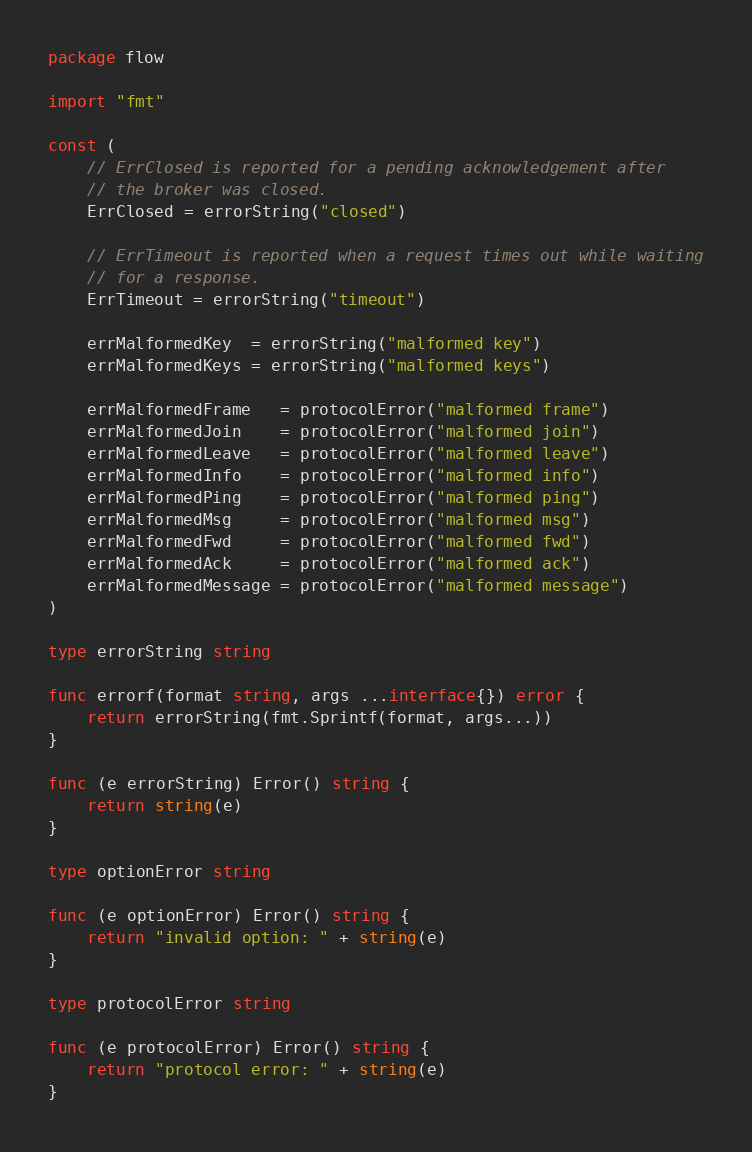<code> <loc_0><loc_0><loc_500><loc_500><_Go_>package flow

import "fmt"

const (
	// ErrClosed is reported for a pending acknowledgement after
	// the broker was closed.
	ErrClosed = errorString("closed")

	// ErrTimeout is reported when a request times out while waiting
	// for a response.
	ErrTimeout = errorString("timeout")

	errMalformedKey  = errorString("malformed key")
	errMalformedKeys = errorString("malformed keys")

	errMalformedFrame   = protocolError("malformed frame")
	errMalformedJoin    = protocolError("malformed join")
	errMalformedLeave   = protocolError("malformed leave")
	errMalformedInfo    = protocolError("malformed info")
	errMalformedPing    = protocolError("malformed ping")
	errMalformedMsg     = protocolError("malformed msg")
	errMalformedFwd     = protocolError("malformed fwd")
	errMalformedAck     = protocolError("malformed ack")
	errMalformedMessage = protocolError("malformed message")
)

type errorString string

func errorf(format string, args ...interface{}) error {
	return errorString(fmt.Sprintf(format, args...))
}

func (e errorString) Error() string {
	return string(e)
}

type optionError string

func (e optionError) Error() string {
	return "invalid option: " + string(e)
}

type protocolError string

func (e protocolError) Error() string {
	return "protocol error: " + string(e)
}
</code> 